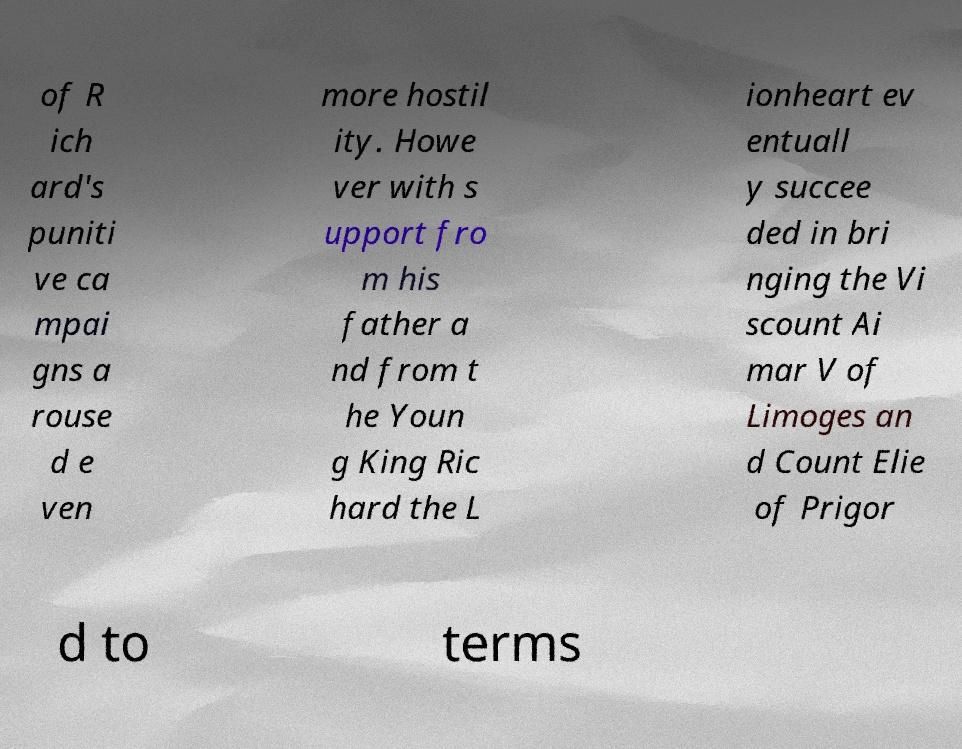Can you read and provide the text displayed in the image?This photo seems to have some interesting text. Can you extract and type it out for me? of R ich ard's puniti ve ca mpai gns a rouse d e ven more hostil ity. Howe ver with s upport fro m his father a nd from t he Youn g King Ric hard the L ionheart ev entuall y succee ded in bri nging the Vi scount Ai mar V of Limoges an d Count Elie of Prigor d to terms 